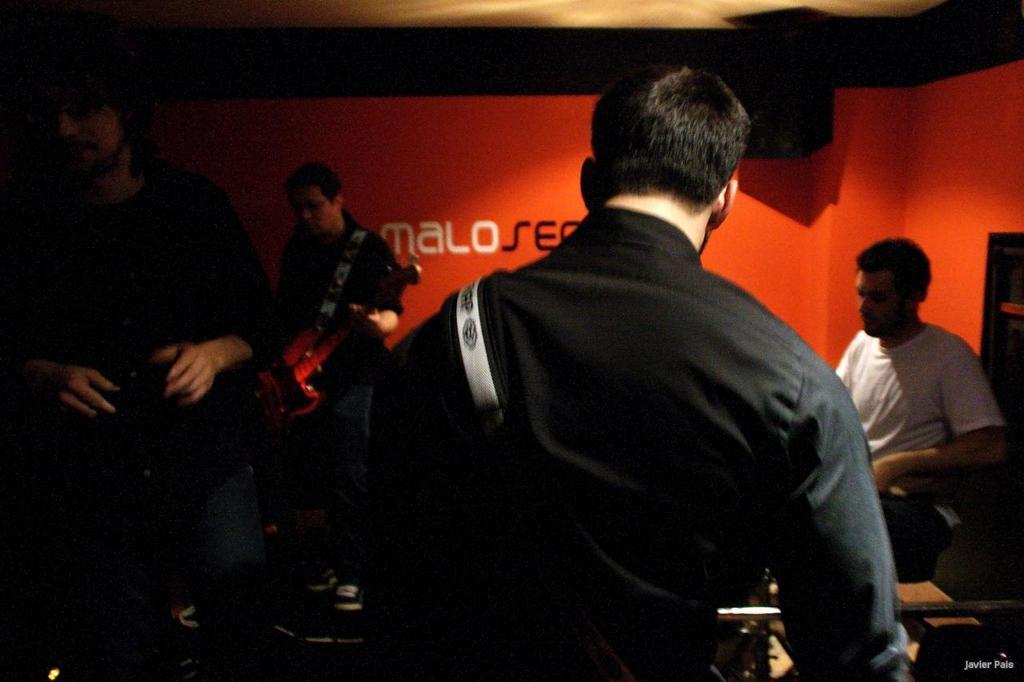Describe this image in one or two sentences. There are four people in a room. They are playing a musical instruments. 